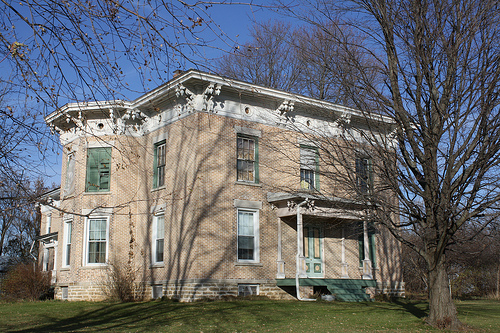<image>
Is the tree behind the house? No. The tree is not behind the house. From this viewpoint, the tree appears to be positioned elsewhere in the scene. 